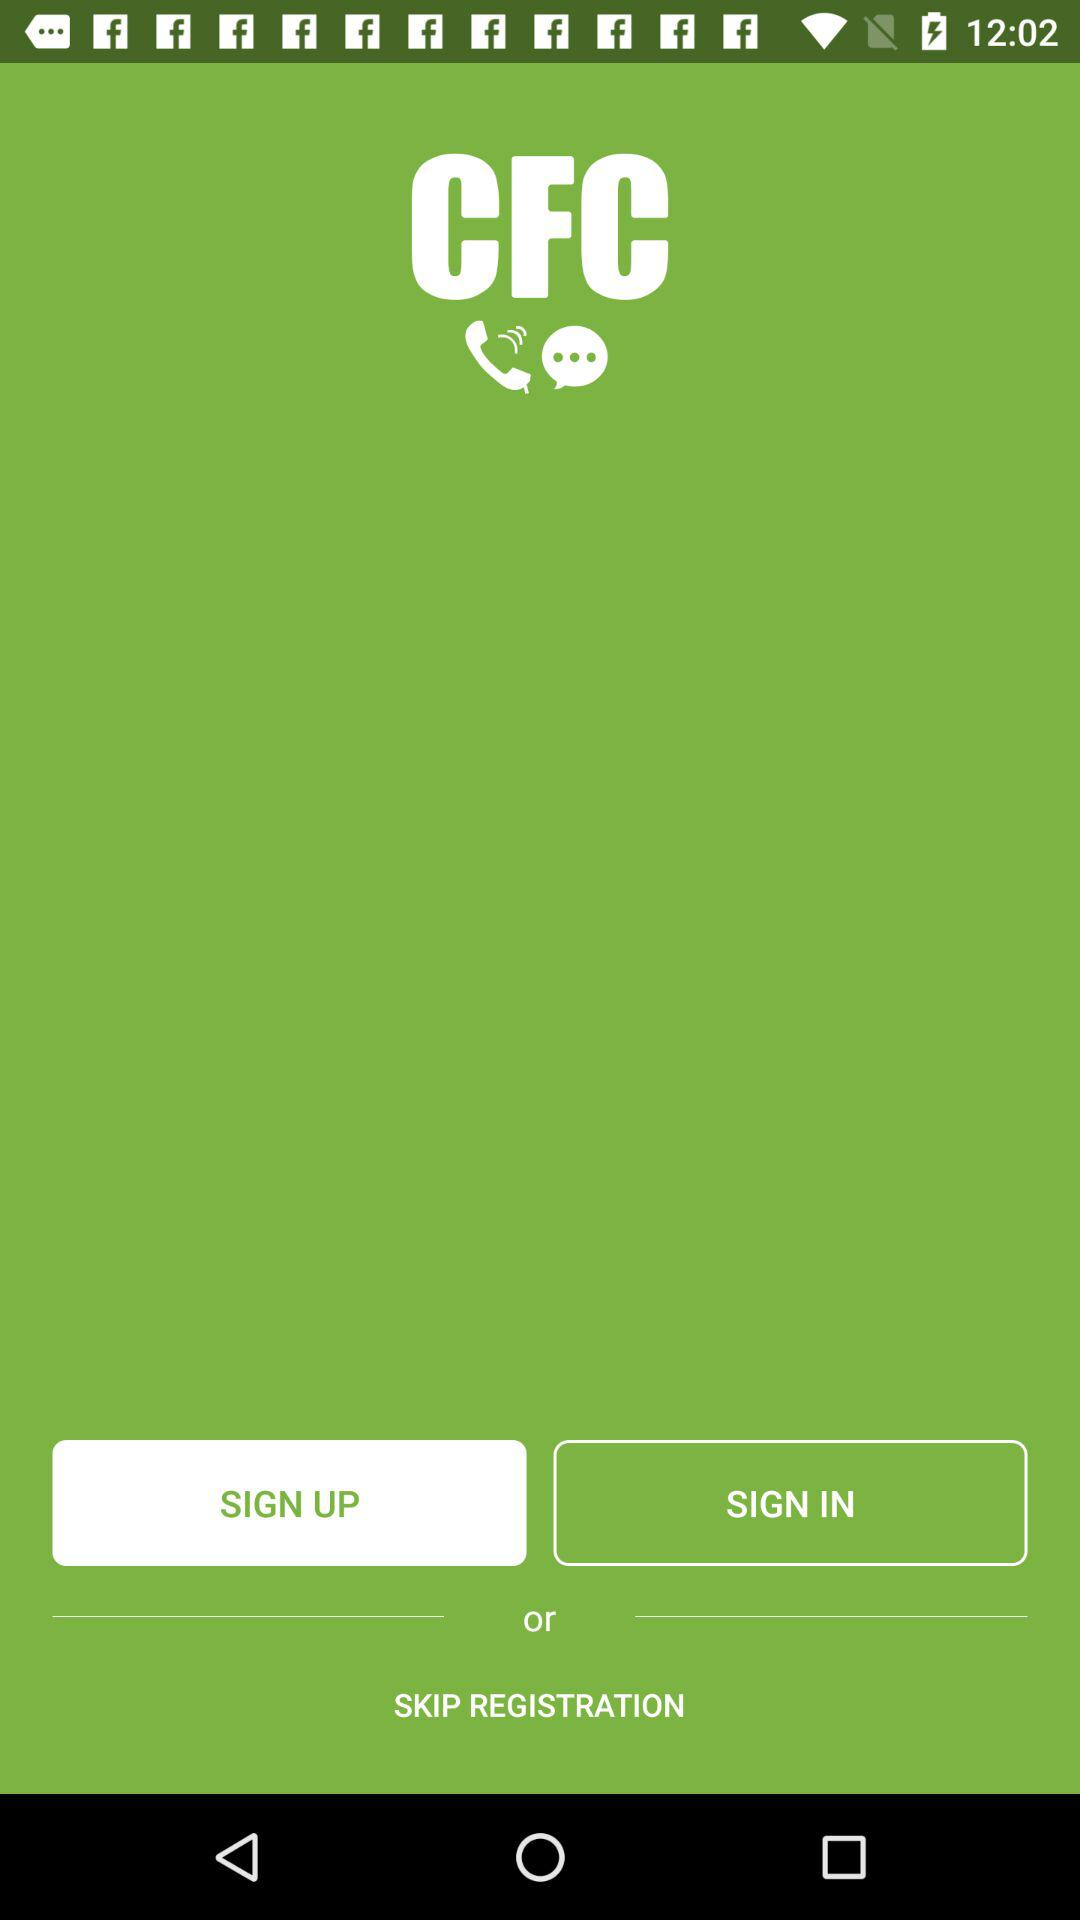What is the name of the application? The name of the application is "CFC". 